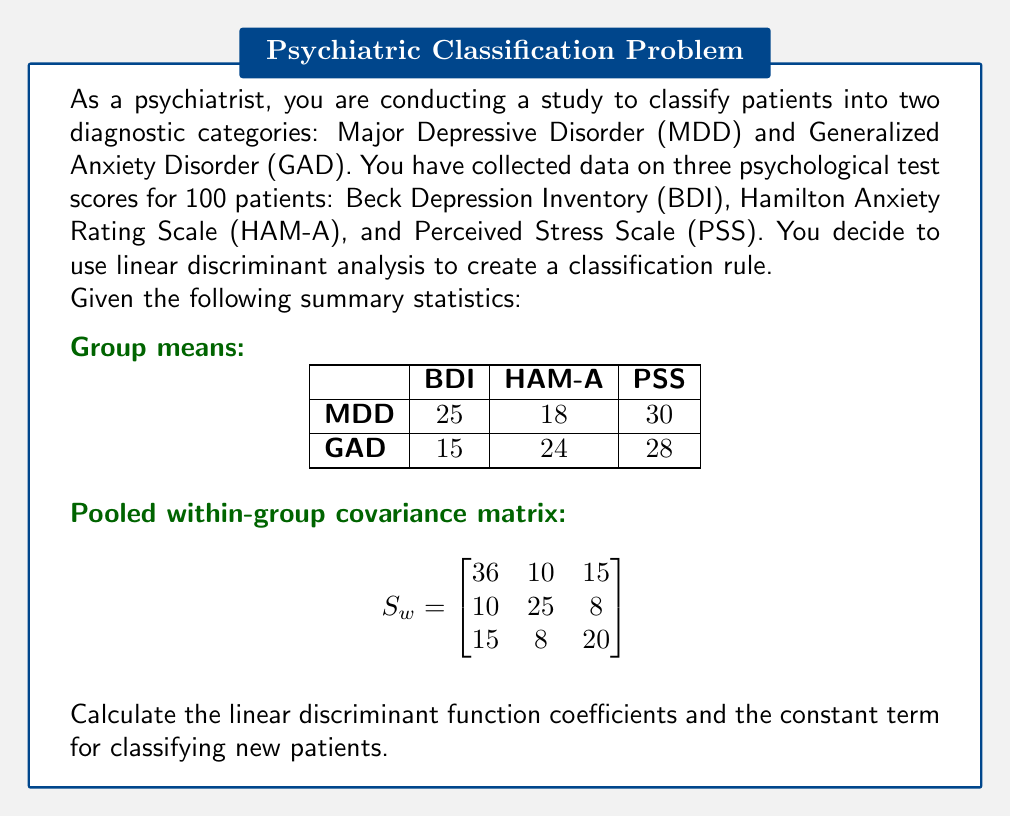Could you help me with this problem? To calculate the linear discriminant function coefficients and constant term, we'll follow these steps:

1) The linear discriminant function has the form:
   $$ L = a_1X_1 + a_2X_2 + a_3X_3 + c $$
   where $X_1$, $X_2$, and $X_3$ are the BDI, HAM-A, and PSS scores respectively.

2) Calculate the difference between group means:
   $$ \bar{x}_{\text{MDD}} - \bar{x}_{\text{GAD}} = [25-15, 18-24, 30-28] = [10, -6, 2] $$

3) Calculate the coefficient vector $\mathbf{a}$ using the formula:
   $$ \mathbf{a} = S_w^{-1}(\bar{x}_{\text{MDD}} - \bar{x}_{\text{GAD}}) $$

4) First, we need to find $S_w^{-1}$:
   $$ S_w^{-1} = \begin{bmatrix}
   0.0347 & -0.0140 & -0.0245 \\
   -0.0140 & 0.0474 & -0.0105 \\
   -0.0245 & -0.0105 & 0.0614
   \end{bmatrix} $$

5) Now, we can calculate $\mathbf{a}$:
   $$ \mathbf{a} = \begin{bmatrix}
   0.0347 & -0.0140 & -0.0245 \\
   -0.0140 & 0.0474 & -0.0105 \\
   -0.0245 & -0.0105 & 0.0614
   \end{bmatrix} \begin{bmatrix} 10 \\ -6 \\ 2 \end{bmatrix} = \begin{bmatrix} 0.4348 \\ -0.3594 \\ 0.0380 \end{bmatrix} $$

6) The constant term $c$ is calculated as:
   $$ c = -\frac{1}{2}\mathbf{a}^T(\bar{x}_{\text{MDD}} + \bar{x}_{\text{GAD}}) $$
   $$ c = -\frac{1}{2}[0.4348, -0.3594, 0.0380] \begin{bmatrix} 40 \\ 42 \\ 58 \end{bmatrix} = -5.1742 $$

Therefore, the linear discriminant function is:
$$ L = 0.4348X_1 - 0.3594X_2 + 0.0380X_3 - 5.1742 $$

Where $X_1$ is BDI, $X_2$ is HAM-A, and $X_3$ is PSS. A new patient would be classified as MDD if $L > 0$, and as GAD if $L < 0$.
Answer: $L = 0.4348X_1 - 0.3594X_2 + 0.0380X_3 - 5.1742$ 